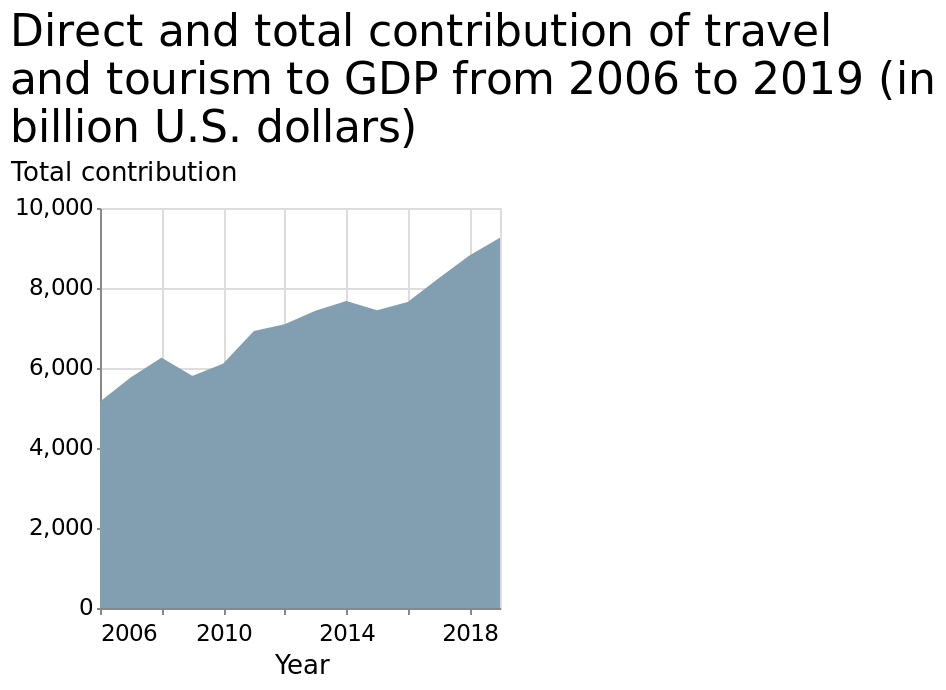<image>
When was the total contribution of travel and tourism to GDP at its highest point? The total contribution of travel and tourism to GDP was at its highest in 2019. Has the total contribution of travel and tourism to GDP consistently increased or fluctuated during the period from 2006 to 2019? The total contribution of travel and tourism to GDP has consistently increased from 2006 to 2019. What is the title of the area plot? The title of the area plot is "Direct and total contribution of travel and tourism to GDP from 2006 to 2019 (in billion U.S. dollars)". When was the total contribution of travel and tourism to GDP at its lowest point? The total contribution of travel and tourism to GDP was at its lowest in 2006. What can be inferred about the economic importance of travel and tourism based on the graph? The graph indicates that travel and tourism have become increasingly important to the overall GDP over the years, with the highest contribution recorded in 2019. please enumerates aspects of the construction of the chart Here a area plot is titled Direct and total contribution of travel and tourism to GDP from 2006 to 2019 (in billion U.S. dollars). The y-axis shows Total contribution as linear scale with a minimum of 0 and a maximum of 10,000 while the x-axis plots Year on linear scale from 2006 to 2018. What does the y-axis represent? The y-axis represents the total contribution as a linear scale from 0 to 10,000. Offer a thorough analysis of the image. The total contribution of travel and tourism has steadily increased since 2010. 